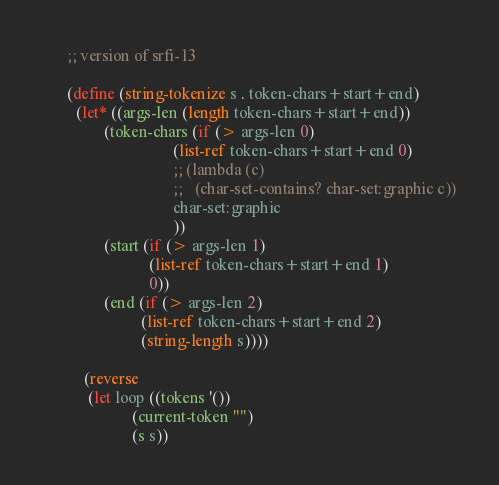Convert code to text. <code><loc_0><loc_0><loc_500><loc_500><_Scheme_>      ;; version of srfi-13

      (define (string-tokenize s . token-chars+start+end)
        (let* ((args-len (length token-chars+start+end))
               (token-chars (if (> args-len 0)
                                (list-ref token-chars+start+end 0)
                                ;; (lambda (c)
                                ;;   (char-set-contains? char-set:graphic c))
                                char-set:graphic
                                ))
               (start (if (> args-len 1)
                          (list-ref token-chars+start+end 1)
                          0))
               (end (if (> args-len 2)
                        (list-ref token-chars+start+end 2)
                        (string-length s))))

          (reverse
           (let loop ((tokens '())
                      (current-token "")
                      (s s))</code> 